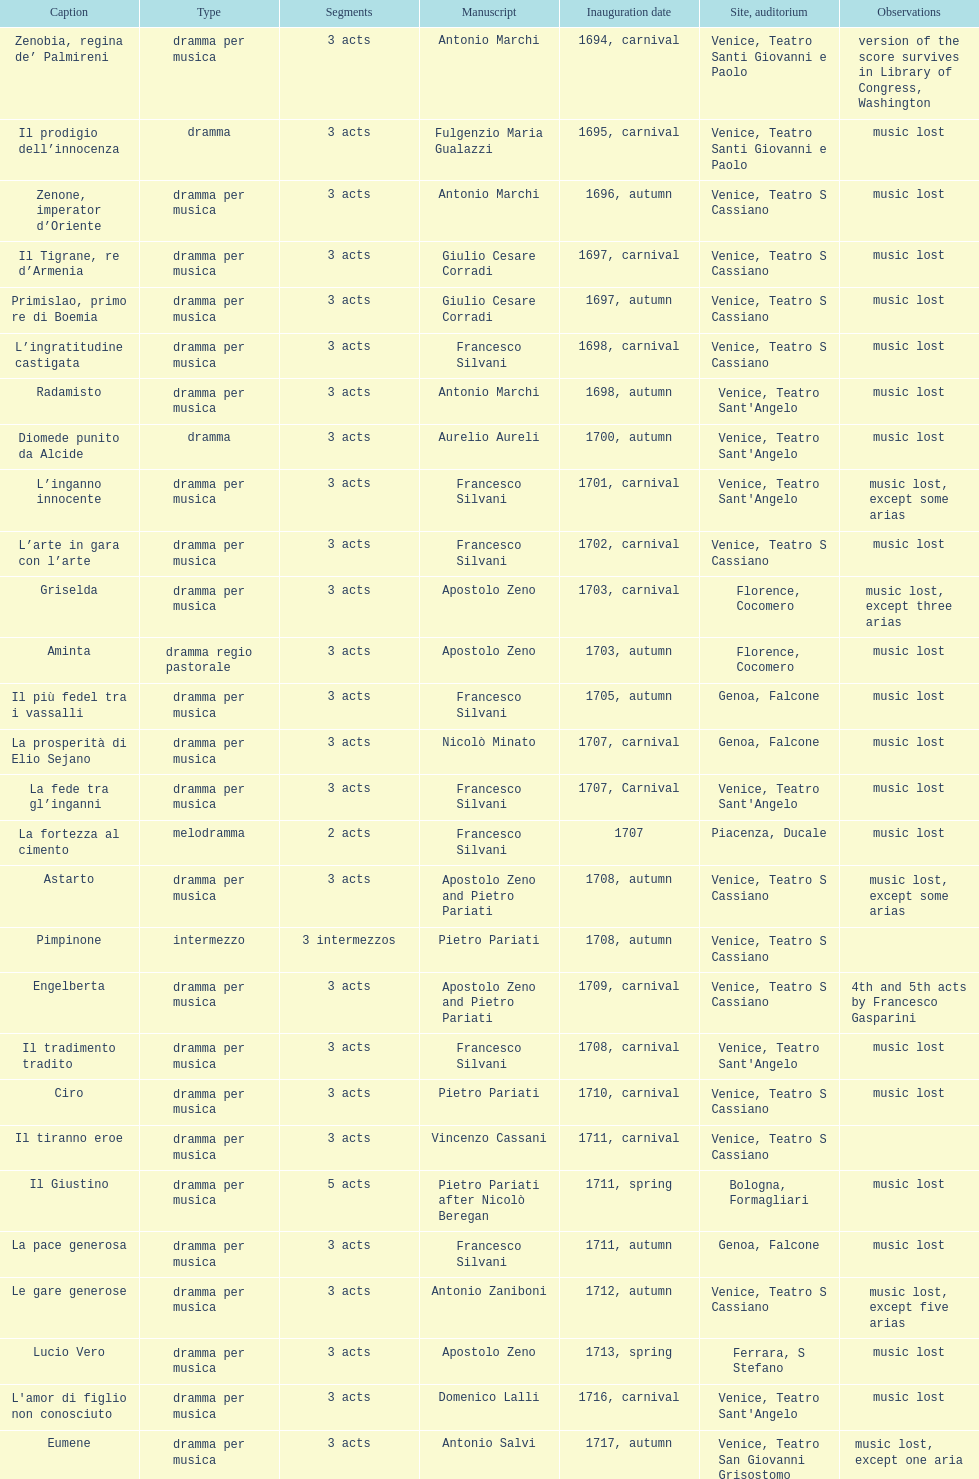How many operas on this list has at least 3 acts? 51. 